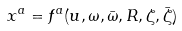<formula> <loc_0><loc_0><loc_500><loc_500>x ^ { a } = f ^ { a } ( u , \omega , \bar { \omega } , R , \zeta , \bar { \zeta } )</formula> 